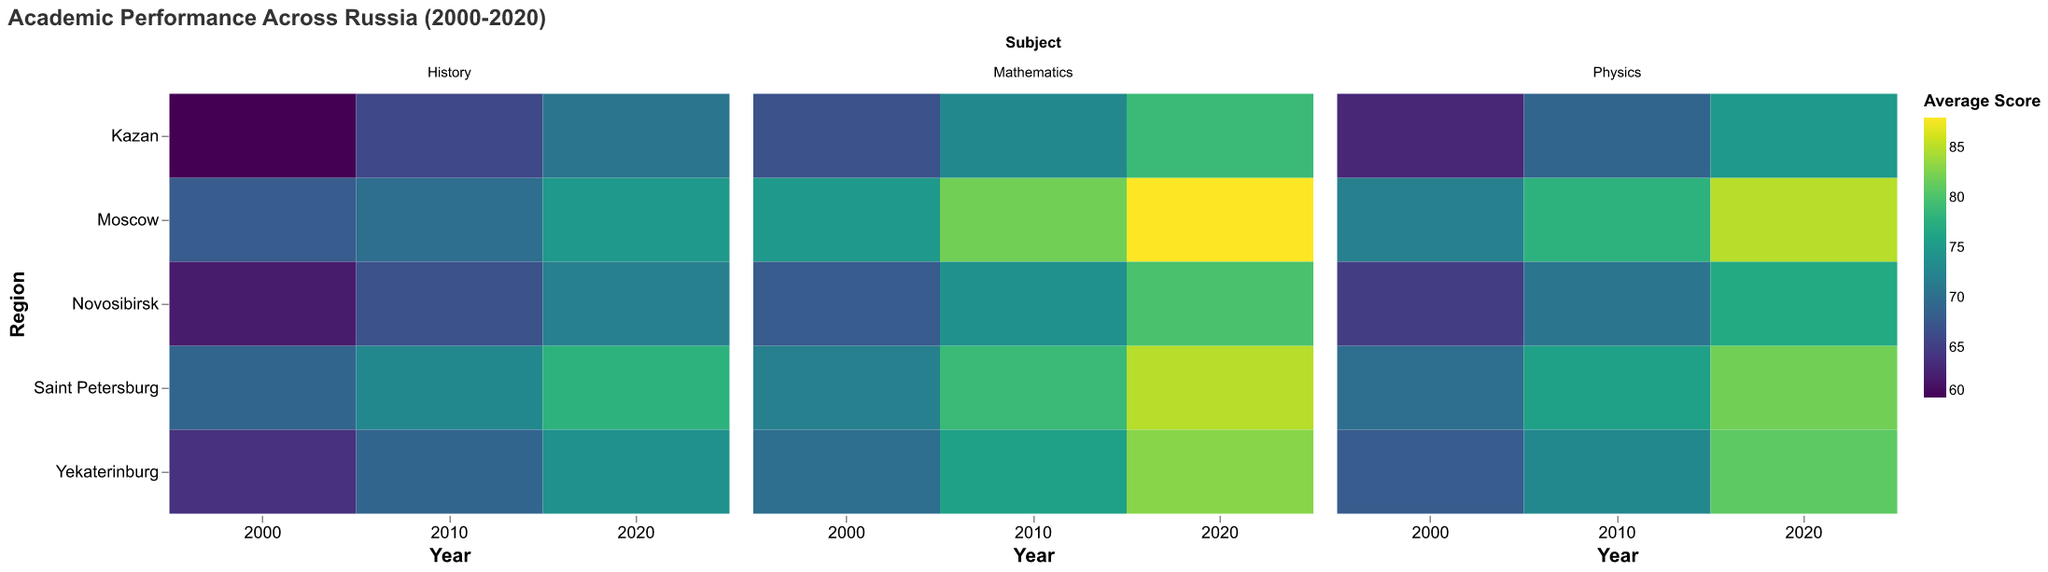What is the average score for Mathematics in Moscow in 2020? Find the cell corresponding to Moscow in 2020 under the Mathematics facet. The color intensity or the label shows 88
Answer: 88 Which region showed the greatest improvement in Physics scores from 2000 to 2020? Compare the Physics scores for each region between 2000 and 2020. Calculate the difference in scores for each region: Moscow (85-72=13), Saint Petersburg (82-70=12), Novosibirsk (77-65=12), Yekaterinburg (81-68=13), Kazan (75-63=12). Both Moscow and Yekaterinburg show the greatest improvement with a difference of 13 points
Answer: Moscow and Yekaterinburg How did the average History score in Saint Petersburg change from 2000 to 2020? Check the History scores for Saint Petersburg in 2000 and 2020. The scores are 69 and 78, respectively. The change is 78 - 69 = 9
Answer: Increased by 9 Among all regions, which one had the highest average score in Mathematics in 2010? Look at the Mathematics scores for all regions in 2010. The scores are Moscow (82), Saint Petersburg (79), Novosibirsk (74), Yekaterinburg (76), Kazan (73). The highest score is 82 in Moscow
Answer: Moscow For Physics, which year had the highest average score in Kazan? Compare the Physics scores for Kazan across 2000, 2010, and 2020. The scores are 63, 69, and 75, respectively. The highest average score is 75 in 2020
Answer: 2020 What is the trend in Mathematics scores in Yekaterinburg from 2000 to 2020? Identify the Mathematics scores for Yekaterinburg in 2000, 2010, and 2020. The scores are 70, 76, and 83, showing a steady increase over the years
Answer: Increasing trend Which region consistently had the lowest average History score from 2000 to 2020? Compare the History scores for all regions across 2000, 2010, and 2020. Novosibirsk has 62 (2000), 67 (2010), and 72 (2020), which are consistently the lowest in comparison to other regions
Answer: Novosibirsk How do the average scores for Physics in 2020 compare between Moscow and Saint Petersburg? Look at the Physics scores for Moscow and Saint Petersburg in 2020. Moscow has a score of 85, while Saint Petersburg has 82. Moscow's score is higher
Answer: Moscow is higher by 3 Which subject had the most significant average score increase in Moscow between 2000 and 2020? Calculate the score increase for each subject in Moscow. Mathematics (88-75=13), History (75-68=7), Physics (85-72=13). Both Mathematics and Physics had the most significant increase of 13 points
Answer: Mathematics and Physics What was the average score for History in Kazan in 2010? Find the cell corresponding to Kazan in 2010 under the History facet. The color intensity or the label shows 66
Answer: 66 